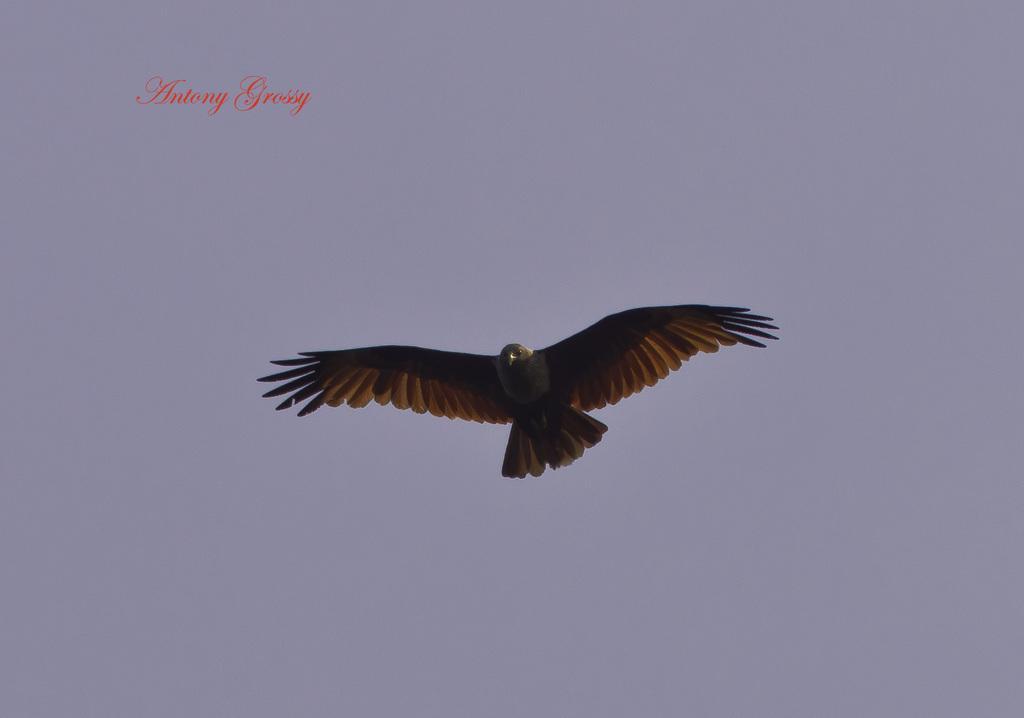Describe this image in one or two sentences. In this image, in the middle, we can see a bird flying in the air. In the background, we can see a sky. 